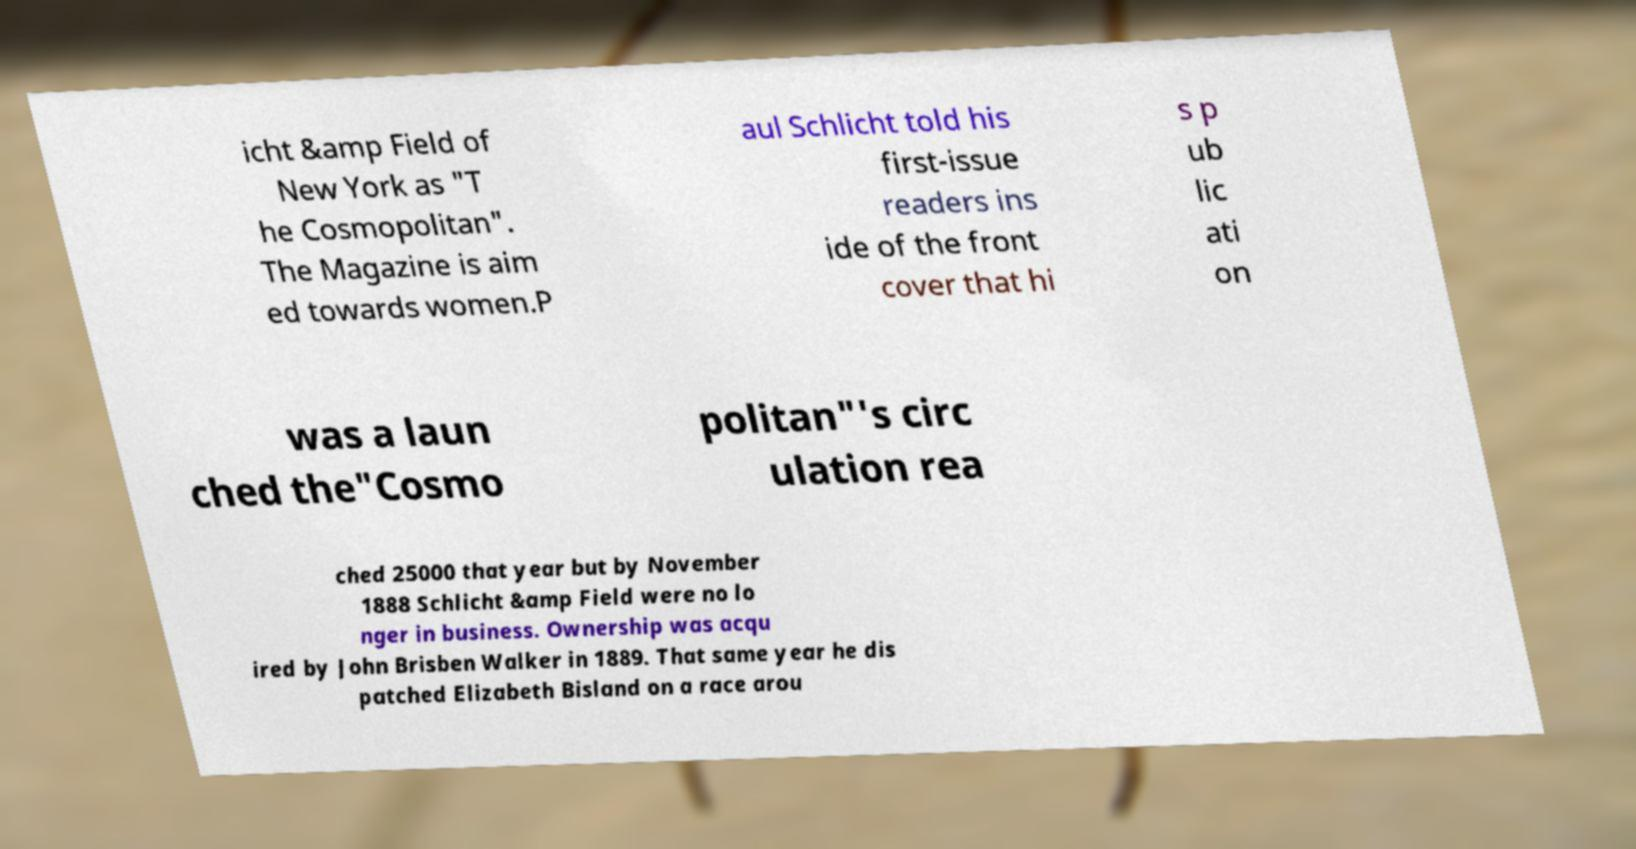Can you read and provide the text displayed in the image?This photo seems to have some interesting text. Can you extract and type it out for me? icht &amp Field of New York as "T he Cosmopolitan". The Magazine is aim ed towards women.P aul Schlicht told his first-issue readers ins ide of the front cover that hi s p ub lic ati on was a laun ched the"Cosmo politan"'s circ ulation rea ched 25000 that year but by November 1888 Schlicht &amp Field were no lo nger in business. Ownership was acqu ired by John Brisben Walker in 1889. That same year he dis patched Elizabeth Bisland on a race arou 